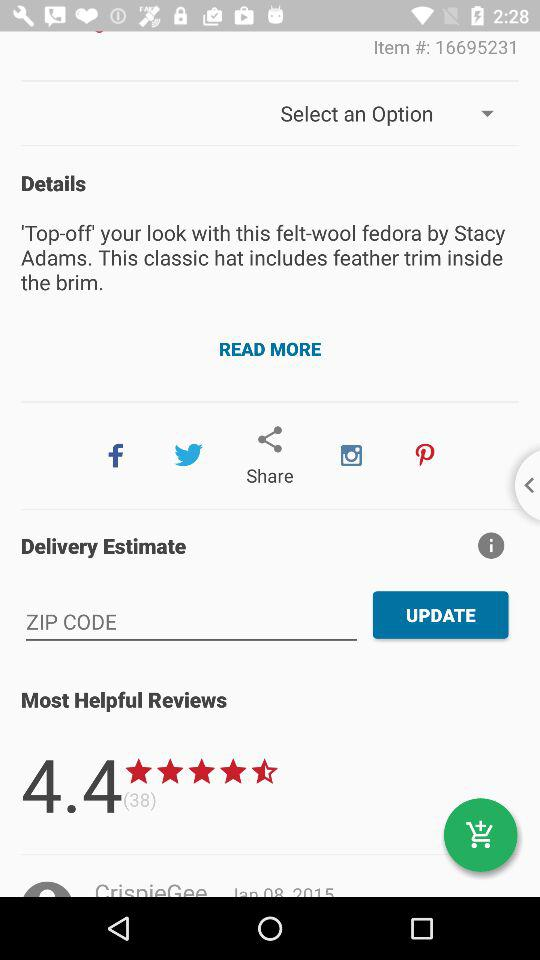What is the item number shown on the screen? The item number is 16695231. 